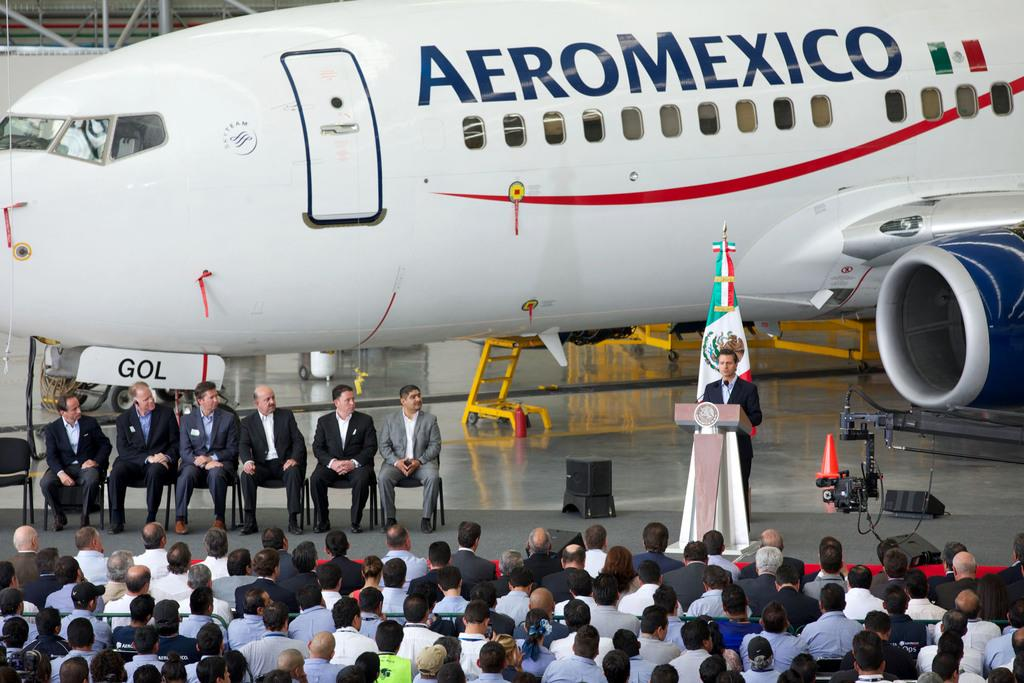<image>
Summarize the visual content of the image. A person giving a speech in front of an airplane from the company Aero Mexico 